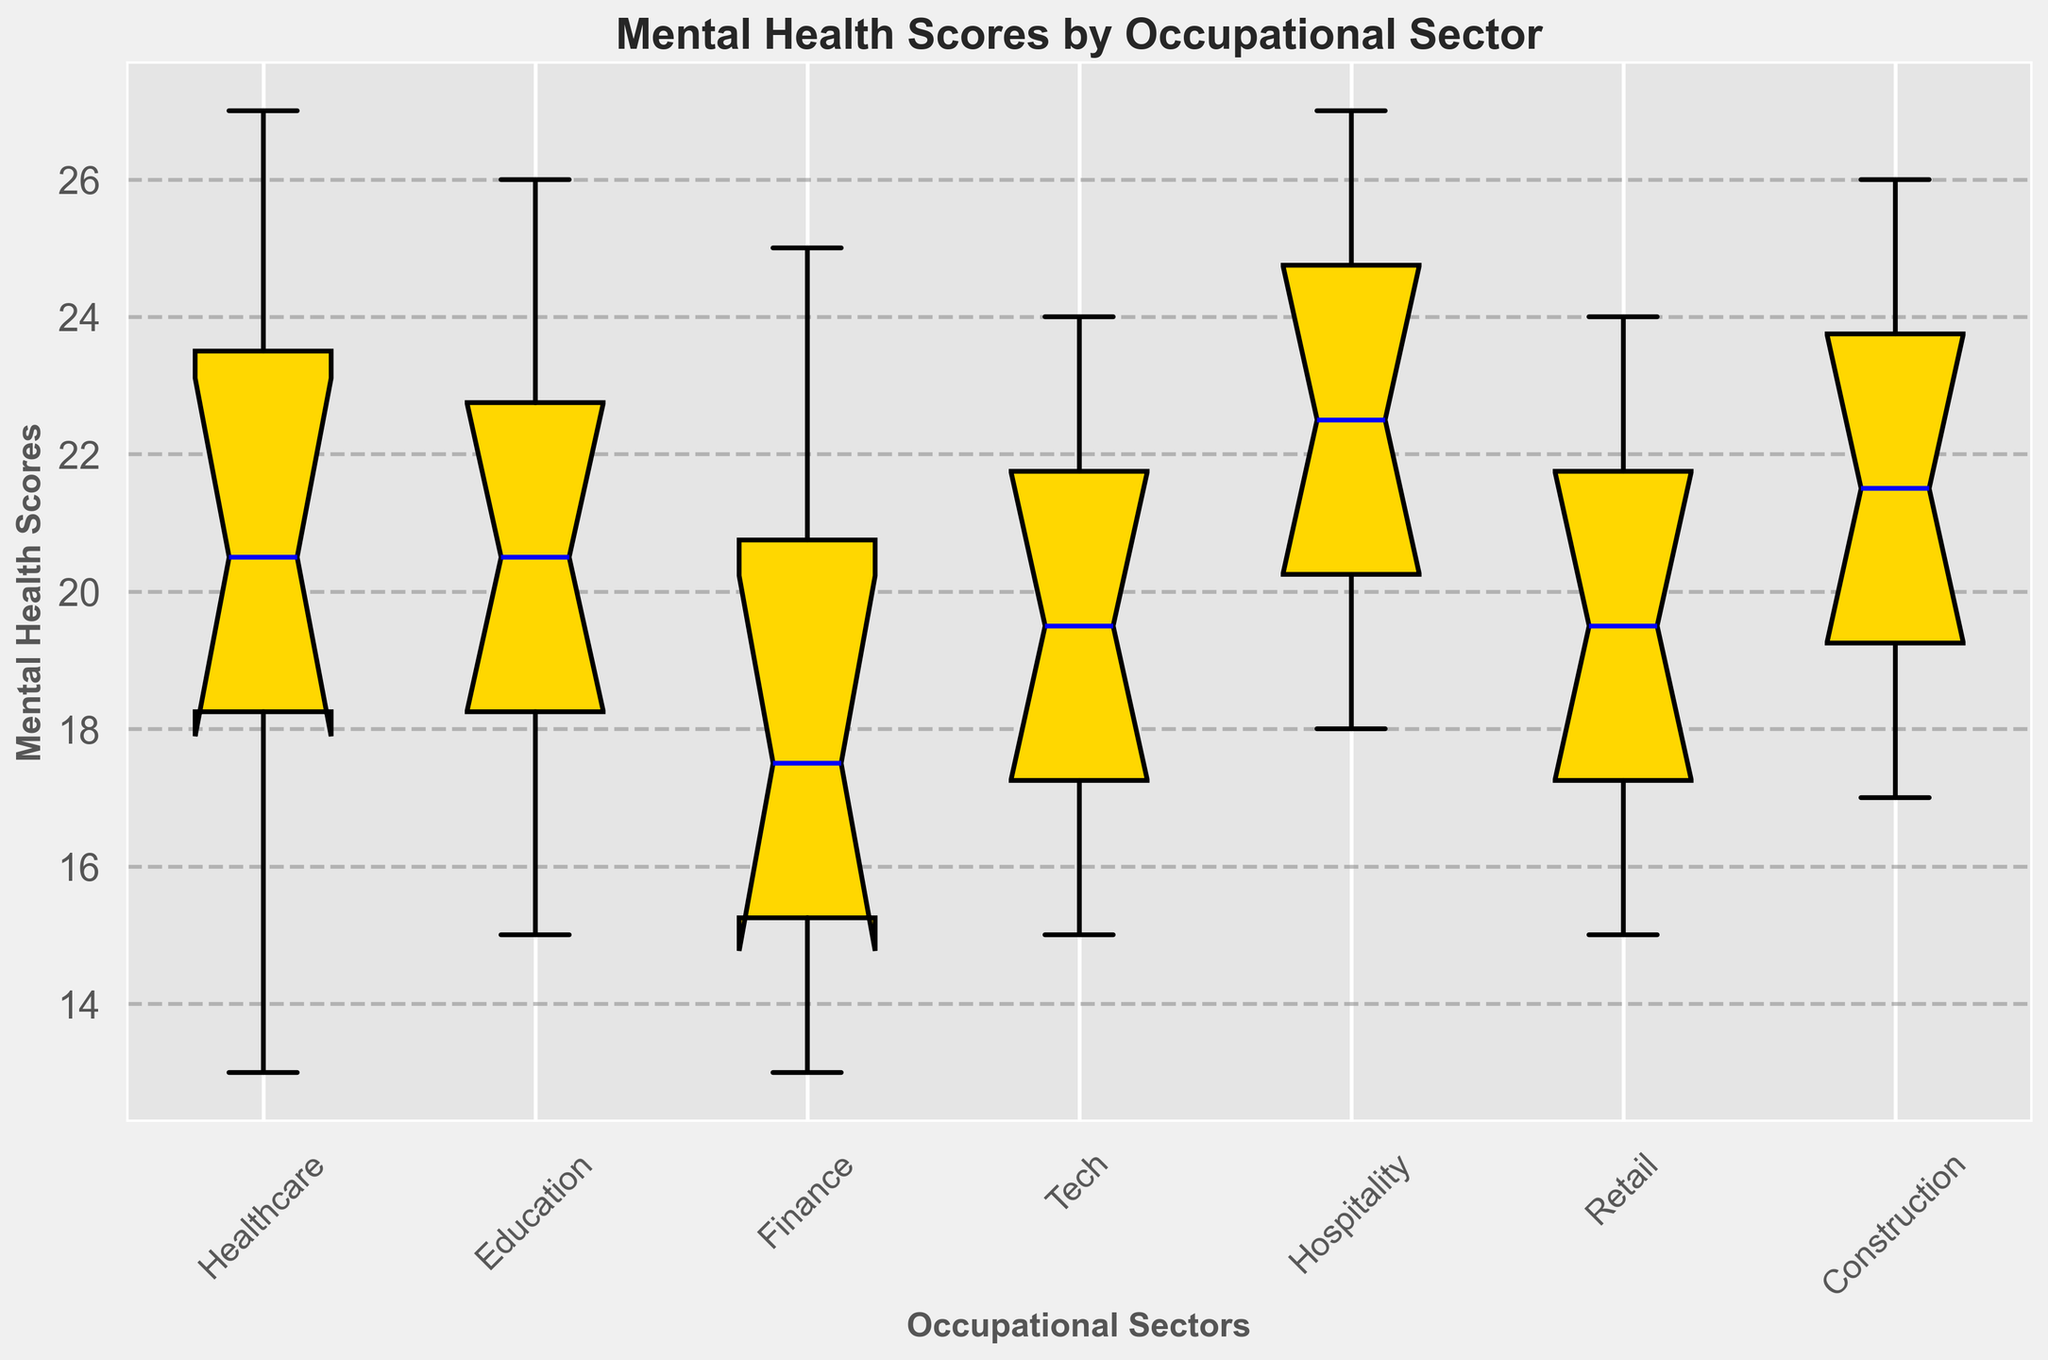What is the median Mental Health Score for the Healthcare sector? Examine the box plot for the Healthcare sector and identify the line inside the box, which represents the median.
Answer: 20.5 Which occupational sector has the highest median Mental Health Score? Look across the boxes for each sector and find the one where the median line is at the highest point on the y-axis.
Answer: Hospitality How do the medians of the Finance and Education sectors compare? Identify the medians for both the Finance and Education sectors by finding the lines inside each box and compare their heights.
Answer: Education > Finance What is the interquartile range (IQR) for the Tech sector? Locate the first quartile (Q1) and third quartile (Q3) lines for the Tech sector's box and subtract Q1 from Q3.
Answer: 7 (23 - 16) Which sector has the widest range of Mental Health Scores, based on the whiskers? Observe the length of the whiskers (the lines extending from the boxes) for each sector and identify the one that spans the greatest distance on the y-axis.
Answer: Finance Is there any overlap between the interquartile ranges of the Healthcare and Retail sectors? Compare the boxes (representing the IQRs) of Healthcare and Retail sectors and see if they share any common values on the y-axis.
Answer: Yes Which sector has the lowest minimum Mental Health Score? Observe the lowest points of the whiskers for each sector and identify the one that drops the lowest on the y-axis.
Answer: Finance Compare the interquartile range (IQR) of the Hospitality sector with that of the Construction sector. Calculate the IQRs for both Hospitality and Construction sectors by subtracting their Q1 from Q3, and then compare these values.
Answer: Hospitality = Construction How does the overall spread (range between min and max) of Mental Health Scores in the Education sector compare to that in the Tech sector? Identify the minimum and maximum values for both Education and Tech sectors by looking at the ends of their whiskers and subtracting the minimum value from the maximum value for each sector. Then compare the results.
Answer: Education = Tech (both 11) Which sectors have outliers, and how are they visually identified? Look for any markers outside the whiskers' end in each sector's box plot. These markers indicate outliers.
Answer: None 